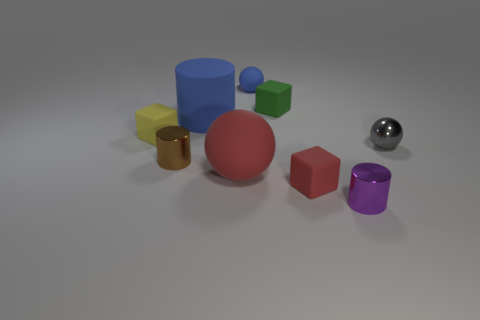Subtract all purple cubes. Subtract all cyan spheres. How many cubes are left? 3 Add 1 tiny yellow matte cubes. How many objects exist? 10 Subtract all cylinders. How many objects are left? 6 Subtract all large blue cubes. Subtract all red blocks. How many objects are left? 8 Add 1 metallic spheres. How many metallic spheres are left? 2 Add 6 red shiny spheres. How many red shiny spheres exist? 6 Subtract 0 purple balls. How many objects are left? 9 